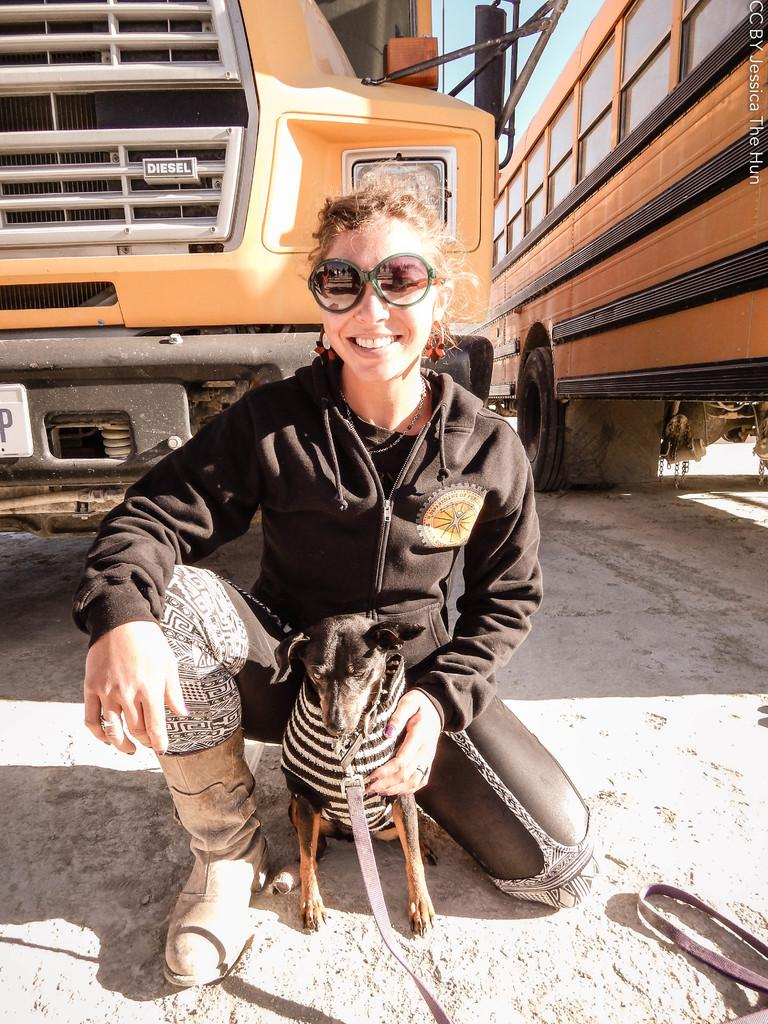Who is the main subject in the image? There is a lady in the image. What is the lady wearing? The lady is wearing a black jacket. What is the lady holding in the image? The lady is holding a dog. What can be seen in the background of the image? There are two buses in the background of the image. What type of head is visible on the dog in the image? There is no head visible on the dog in the image, as the lady is holding the dog and only its body is visible. 